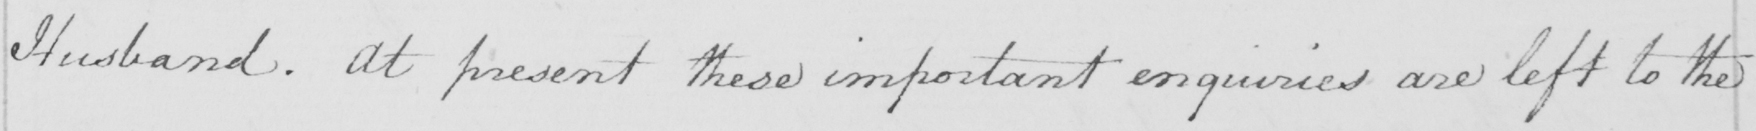What is written in this line of handwriting? Husband. At present these important enquiries are left to the 